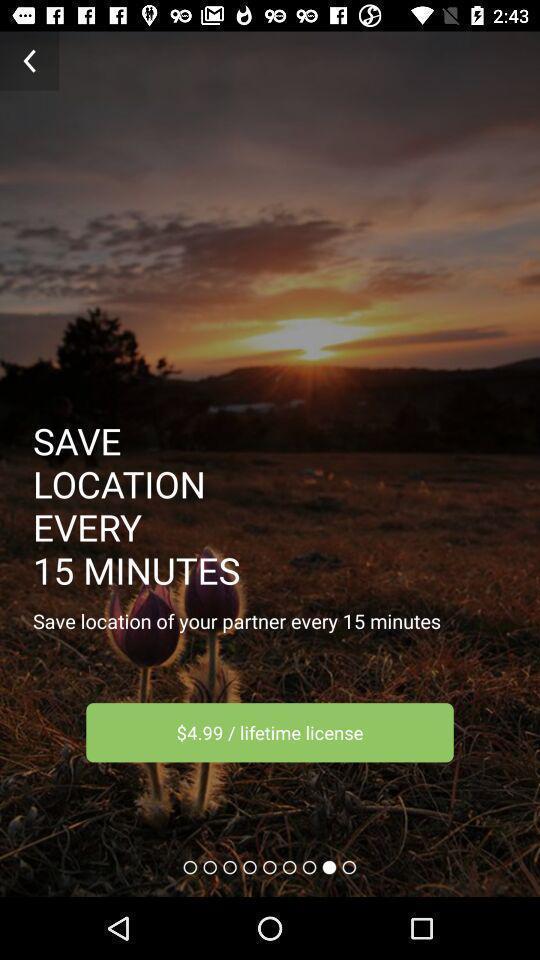What is the overall content of this screenshot? Page displaying to save location. 